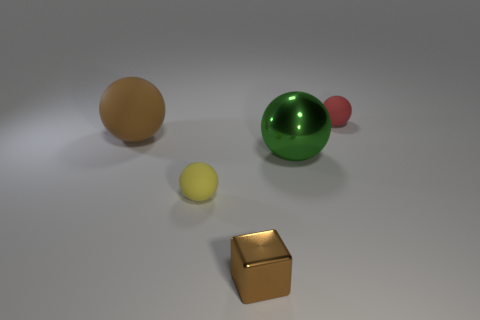What shape is the brown thing that is on the right side of the tiny matte sphere in front of the large brown matte sphere?
Offer a very short reply. Cube. There is a red object; are there any metal cubes behind it?
Give a very brief answer. No. The other shiny sphere that is the same size as the brown ball is what color?
Provide a short and direct response. Green. How many other tiny balls have the same material as the red sphere?
Provide a succinct answer. 1. How many other things are the same size as the red rubber thing?
Your answer should be very brief. 2. Are there any red metallic cylinders that have the same size as the red matte ball?
Offer a terse response. No. There is a tiny ball in front of the big rubber ball; is its color the same as the cube?
Keep it short and to the point. No. What number of things are either red matte spheres or brown objects?
Your response must be concise. 3. There is a shiny object that is right of the metallic block; is its size the same as the tiny brown object?
Your response must be concise. No. What size is the rubber sphere that is both behind the green thing and left of the small red thing?
Give a very brief answer. Large. 